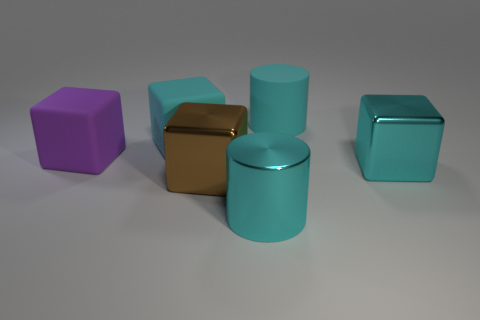What number of large purple rubber things are the same shape as the big brown shiny object?
Your answer should be compact. 1. There is a large cyan object that is in front of the cyan rubber block and behind the shiny cylinder; what is its material?
Provide a short and direct response. Metal. There is a big brown thing; how many large rubber things are in front of it?
Your answer should be compact. 0. How many small red metallic spheres are there?
Provide a short and direct response. 0. Do the purple block and the cyan matte cylinder have the same size?
Offer a very short reply. Yes. Is there a large cyan metallic object to the left of the cyan cylinder to the right of the big shiny thing that is in front of the brown cube?
Keep it short and to the point. Yes. What is the material of the purple object that is the same shape as the large brown metallic thing?
Provide a short and direct response. Rubber. The big metal cube that is behind the big brown cube is what color?
Provide a succinct answer. Cyan. The cyan shiny cube is what size?
Your answer should be very brief. Large. There is a brown metal object; is its size the same as the block that is behind the big purple rubber cube?
Your answer should be very brief. Yes. 